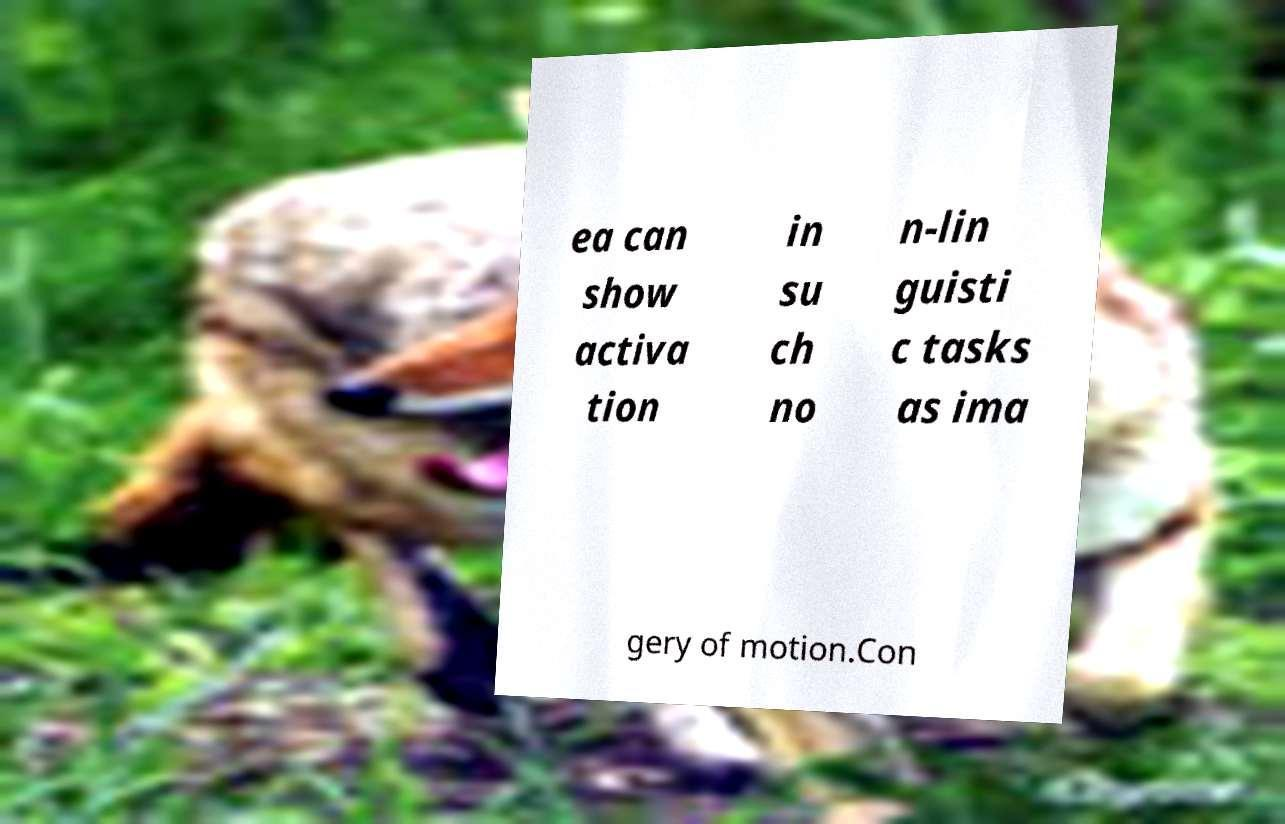Can you read and provide the text displayed in the image?This photo seems to have some interesting text. Can you extract and type it out for me? ea can show activa tion in su ch no n-lin guisti c tasks as ima gery of motion.Con 